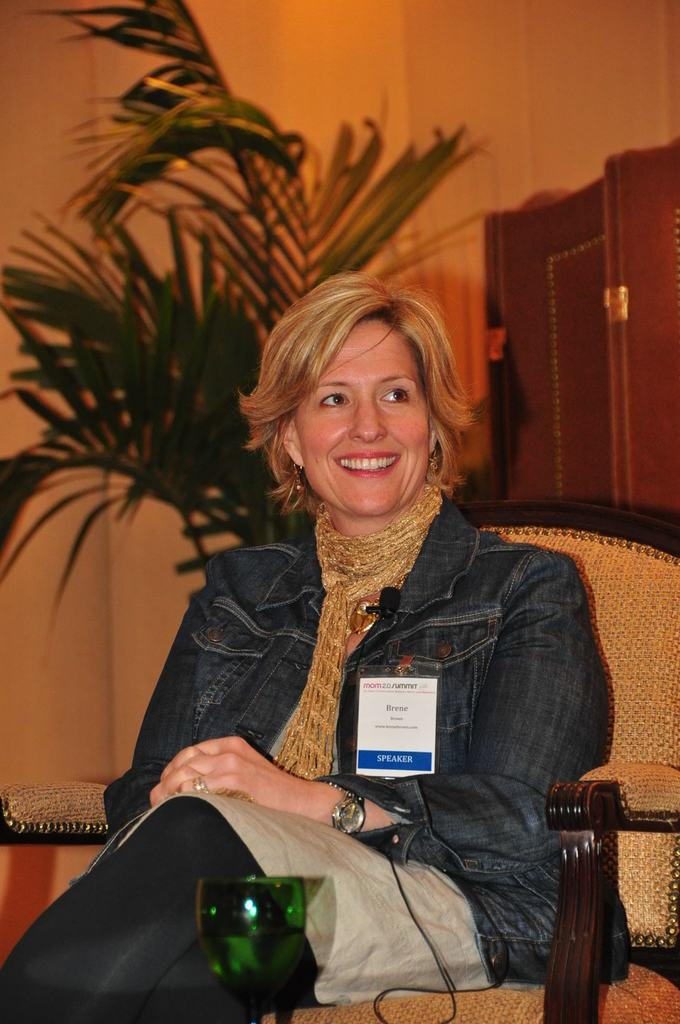Who is present in the image? There is a woman in the image. What is the woman doing in the image? The woman is sitting on a chair in the image. What can be seen in the background of the image? There is a plant and a cupboard in the background of the image. What is the woman wearing that is related to her activity? The woman has a microphone attached to her jacket. What type of pan is the woman using to cook in the image? There is no pan or cooking activity present in the image. What kind of wine is the woman holding in the image? There is no wine present in the image. 